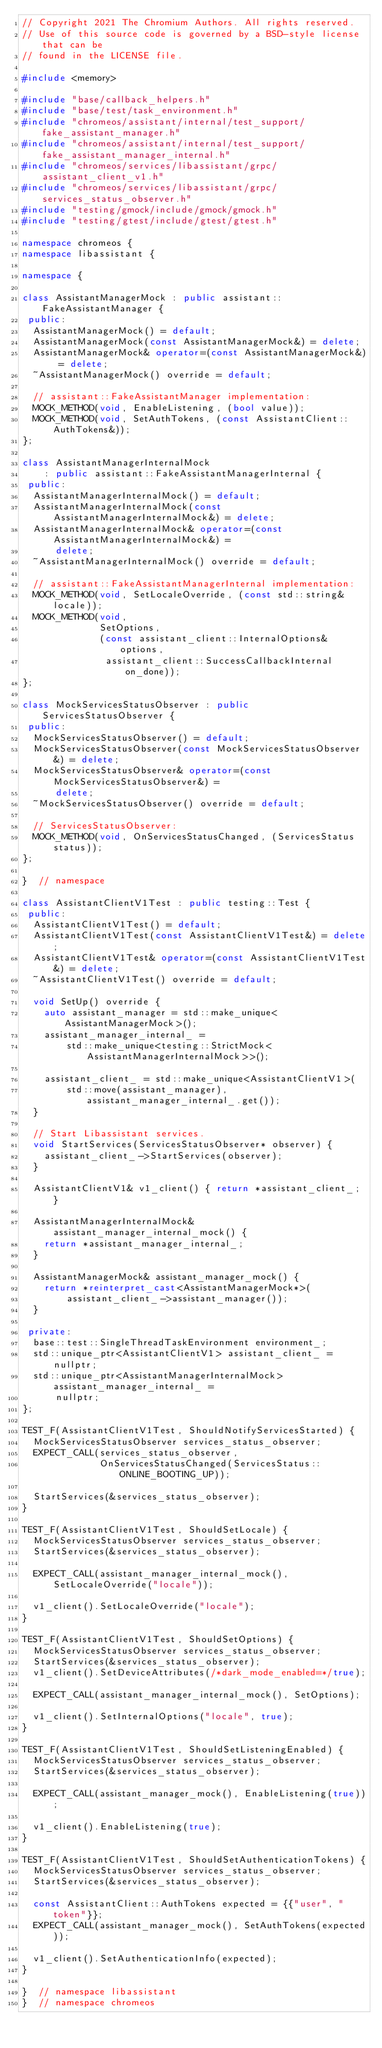<code> <loc_0><loc_0><loc_500><loc_500><_C++_>// Copyright 2021 The Chromium Authors. All rights reserved.
// Use of this source code is governed by a BSD-style license that can be
// found in the LICENSE file.

#include <memory>

#include "base/callback_helpers.h"
#include "base/test/task_environment.h"
#include "chromeos/assistant/internal/test_support/fake_assistant_manager.h"
#include "chromeos/assistant/internal/test_support/fake_assistant_manager_internal.h"
#include "chromeos/services/libassistant/grpc/assistant_client_v1.h"
#include "chromeos/services/libassistant/grpc/services_status_observer.h"
#include "testing/gmock/include/gmock/gmock.h"
#include "testing/gtest/include/gtest/gtest.h"

namespace chromeos {
namespace libassistant {

namespace {

class AssistantManagerMock : public assistant::FakeAssistantManager {
 public:
  AssistantManagerMock() = default;
  AssistantManagerMock(const AssistantManagerMock&) = delete;
  AssistantManagerMock& operator=(const AssistantManagerMock&) = delete;
  ~AssistantManagerMock() override = default;

  // assistant::FakeAssistantManager implementation:
  MOCK_METHOD(void, EnableListening, (bool value));
  MOCK_METHOD(void, SetAuthTokens, (const AssistantClient::AuthTokens&));
};

class AssistantManagerInternalMock
    : public assistant::FakeAssistantManagerInternal {
 public:
  AssistantManagerInternalMock() = default;
  AssistantManagerInternalMock(const AssistantManagerInternalMock&) = delete;
  AssistantManagerInternalMock& operator=(const AssistantManagerInternalMock&) =
      delete;
  ~AssistantManagerInternalMock() override = default;

  // assistant::FakeAssistantManagerInternal implementation:
  MOCK_METHOD(void, SetLocaleOverride, (const std::string& locale));
  MOCK_METHOD(void,
              SetOptions,
              (const assistant_client::InternalOptions& options,
               assistant_client::SuccessCallbackInternal on_done));
};

class MockServicesStatusObserver : public ServicesStatusObserver {
 public:
  MockServicesStatusObserver() = default;
  MockServicesStatusObserver(const MockServicesStatusObserver&) = delete;
  MockServicesStatusObserver& operator=(const MockServicesStatusObserver&) =
      delete;
  ~MockServicesStatusObserver() override = default;

  // ServicesStatusObserver:
  MOCK_METHOD(void, OnServicesStatusChanged, (ServicesStatus status));
};

}  // namespace

class AssistantClientV1Test : public testing::Test {
 public:
  AssistantClientV1Test() = default;
  AssistantClientV1Test(const AssistantClientV1Test&) = delete;
  AssistantClientV1Test& operator=(const AssistantClientV1Test&) = delete;
  ~AssistantClientV1Test() override = default;

  void SetUp() override {
    auto assistant_manager = std::make_unique<AssistantManagerMock>();
    assistant_manager_internal_ =
        std::make_unique<testing::StrictMock<AssistantManagerInternalMock>>();

    assistant_client_ = std::make_unique<AssistantClientV1>(
        std::move(assistant_manager), assistant_manager_internal_.get());
  }

  // Start Libassistant services.
  void StartServices(ServicesStatusObserver* observer) {
    assistant_client_->StartServices(observer);
  }

  AssistantClientV1& v1_client() { return *assistant_client_; }

  AssistantManagerInternalMock& assistant_manager_internal_mock() {
    return *assistant_manager_internal_;
  }

  AssistantManagerMock& assistant_manager_mock() {
    return *reinterpret_cast<AssistantManagerMock*>(
        assistant_client_->assistant_manager());
  }

 private:
  base::test::SingleThreadTaskEnvironment environment_;
  std::unique_ptr<AssistantClientV1> assistant_client_ = nullptr;
  std::unique_ptr<AssistantManagerInternalMock> assistant_manager_internal_ =
      nullptr;
};

TEST_F(AssistantClientV1Test, ShouldNotifyServicesStarted) {
  MockServicesStatusObserver services_status_observer;
  EXPECT_CALL(services_status_observer,
              OnServicesStatusChanged(ServicesStatus::ONLINE_BOOTING_UP));

  StartServices(&services_status_observer);
}

TEST_F(AssistantClientV1Test, ShouldSetLocale) {
  MockServicesStatusObserver services_status_observer;
  StartServices(&services_status_observer);

  EXPECT_CALL(assistant_manager_internal_mock(), SetLocaleOverride("locale"));

  v1_client().SetLocaleOverride("locale");
}

TEST_F(AssistantClientV1Test, ShouldSetOptions) {
  MockServicesStatusObserver services_status_observer;
  StartServices(&services_status_observer);
  v1_client().SetDeviceAttributes(/*dark_mode_enabled=*/true);

  EXPECT_CALL(assistant_manager_internal_mock(), SetOptions);

  v1_client().SetInternalOptions("locale", true);
}

TEST_F(AssistantClientV1Test, ShouldSetListeningEnabled) {
  MockServicesStatusObserver services_status_observer;
  StartServices(&services_status_observer);

  EXPECT_CALL(assistant_manager_mock(), EnableListening(true));

  v1_client().EnableListening(true);
}

TEST_F(AssistantClientV1Test, ShouldSetAuthenticationTokens) {
  MockServicesStatusObserver services_status_observer;
  StartServices(&services_status_observer);

  const AssistantClient::AuthTokens expected = {{"user", "token"}};
  EXPECT_CALL(assistant_manager_mock(), SetAuthTokens(expected));

  v1_client().SetAuthenticationInfo(expected);
}

}  // namespace libassistant
}  // namespace chromeos
</code> 